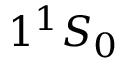<formula> <loc_0><loc_0><loc_500><loc_500>1 ^ { 1 } S _ { 0 }</formula> 